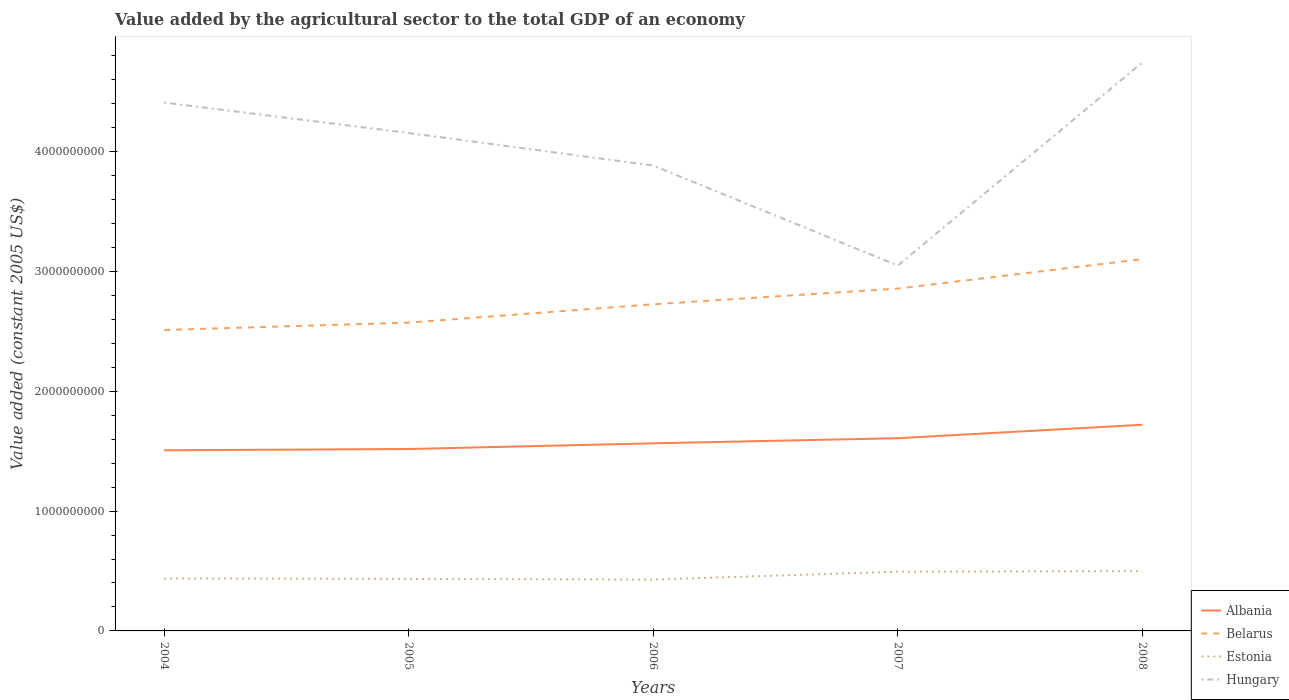How many different coloured lines are there?
Ensure brevity in your answer.  4. Across all years, what is the maximum value added by the agricultural sector in Estonia?
Offer a very short reply. 4.28e+08. In which year was the value added by the agricultural sector in Belarus maximum?
Keep it short and to the point. 2004. What is the total value added by the agricultural sector in Hungary in the graph?
Your answer should be very brief. 2.72e+08. What is the difference between the highest and the second highest value added by the agricultural sector in Estonia?
Ensure brevity in your answer.  7.04e+07. Is the value added by the agricultural sector in Estonia strictly greater than the value added by the agricultural sector in Albania over the years?
Keep it short and to the point. Yes. How many years are there in the graph?
Provide a succinct answer. 5. Does the graph contain grids?
Give a very brief answer. No. Where does the legend appear in the graph?
Provide a succinct answer. Bottom right. How many legend labels are there?
Provide a short and direct response. 4. How are the legend labels stacked?
Offer a terse response. Vertical. What is the title of the graph?
Give a very brief answer. Value added by the agricultural sector to the total GDP of an economy. Does "Sierra Leone" appear as one of the legend labels in the graph?
Offer a terse response. No. What is the label or title of the Y-axis?
Provide a short and direct response. Value added (constant 2005 US$). What is the Value added (constant 2005 US$) of Albania in 2004?
Provide a short and direct response. 1.51e+09. What is the Value added (constant 2005 US$) of Belarus in 2004?
Ensure brevity in your answer.  2.51e+09. What is the Value added (constant 2005 US$) in Estonia in 2004?
Give a very brief answer. 4.38e+08. What is the Value added (constant 2005 US$) of Hungary in 2004?
Ensure brevity in your answer.  4.41e+09. What is the Value added (constant 2005 US$) in Albania in 2005?
Offer a very short reply. 1.52e+09. What is the Value added (constant 2005 US$) of Belarus in 2005?
Offer a very short reply. 2.57e+09. What is the Value added (constant 2005 US$) of Estonia in 2005?
Keep it short and to the point. 4.34e+08. What is the Value added (constant 2005 US$) in Hungary in 2005?
Provide a short and direct response. 4.16e+09. What is the Value added (constant 2005 US$) of Albania in 2006?
Make the answer very short. 1.57e+09. What is the Value added (constant 2005 US$) in Belarus in 2006?
Ensure brevity in your answer.  2.73e+09. What is the Value added (constant 2005 US$) in Estonia in 2006?
Your response must be concise. 4.28e+08. What is the Value added (constant 2005 US$) of Hungary in 2006?
Give a very brief answer. 3.88e+09. What is the Value added (constant 2005 US$) in Albania in 2007?
Give a very brief answer. 1.61e+09. What is the Value added (constant 2005 US$) in Belarus in 2007?
Your response must be concise. 2.86e+09. What is the Value added (constant 2005 US$) in Estonia in 2007?
Your answer should be compact. 4.94e+08. What is the Value added (constant 2005 US$) in Hungary in 2007?
Provide a succinct answer. 3.05e+09. What is the Value added (constant 2005 US$) in Albania in 2008?
Provide a succinct answer. 1.72e+09. What is the Value added (constant 2005 US$) in Belarus in 2008?
Ensure brevity in your answer.  3.10e+09. What is the Value added (constant 2005 US$) in Estonia in 2008?
Your answer should be very brief. 4.99e+08. What is the Value added (constant 2005 US$) of Hungary in 2008?
Your answer should be very brief. 4.75e+09. Across all years, what is the maximum Value added (constant 2005 US$) of Albania?
Your response must be concise. 1.72e+09. Across all years, what is the maximum Value added (constant 2005 US$) in Belarus?
Your response must be concise. 3.10e+09. Across all years, what is the maximum Value added (constant 2005 US$) of Estonia?
Your answer should be very brief. 4.99e+08. Across all years, what is the maximum Value added (constant 2005 US$) in Hungary?
Keep it short and to the point. 4.75e+09. Across all years, what is the minimum Value added (constant 2005 US$) of Albania?
Your answer should be compact. 1.51e+09. Across all years, what is the minimum Value added (constant 2005 US$) in Belarus?
Give a very brief answer. 2.51e+09. Across all years, what is the minimum Value added (constant 2005 US$) of Estonia?
Provide a succinct answer. 4.28e+08. Across all years, what is the minimum Value added (constant 2005 US$) of Hungary?
Your answer should be very brief. 3.05e+09. What is the total Value added (constant 2005 US$) of Albania in the graph?
Your response must be concise. 7.92e+09. What is the total Value added (constant 2005 US$) of Belarus in the graph?
Your answer should be very brief. 1.38e+1. What is the total Value added (constant 2005 US$) in Estonia in the graph?
Ensure brevity in your answer.  2.29e+09. What is the total Value added (constant 2005 US$) of Hungary in the graph?
Keep it short and to the point. 2.02e+1. What is the difference between the Value added (constant 2005 US$) in Albania in 2004 and that in 2005?
Your answer should be very brief. -1.05e+07. What is the difference between the Value added (constant 2005 US$) of Belarus in 2004 and that in 2005?
Your answer should be compact. -6.17e+07. What is the difference between the Value added (constant 2005 US$) of Estonia in 2004 and that in 2005?
Your answer should be compact. 3.88e+06. What is the difference between the Value added (constant 2005 US$) of Hungary in 2004 and that in 2005?
Give a very brief answer. 2.54e+08. What is the difference between the Value added (constant 2005 US$) of Albania in 2004 and that in 2006?
Keep it short and to the point. -5.79e+07. What is the difference between the Value added (constant 2005 US$) of Belarus in 2004 and that in 2006?
Keep it short and to the point. -2.15e+08. What is the difference between the Value added (constant 2005 US$) in Estonia in 2004 and that in 2006?
Your answer should be compact. 9.87e+06. What is the difference between the Value added (constant 2005 US$) in Hungary in 2004 and that in 2006?
Provide a succinct answer. 5.26e+08. What is the difference between the Value added (constant 2005 US$) of Albania in 2004 and that in 2007?
Your response must be concise. -1.01e+08. What is the difference between the Value added (constant 2005 US$) in Belarus in 2004 and that in 2007?
Offer a terse response. -3.46e+08. What is the difference between the Value added (constant 2005 US$) of Estonia in 2004 and that in 2007?
Your answer should be very brief. -5.62e+07. What is the difference between the Value added (constant 2005 US$) of Hungary in 2004 and that in 2007?
Provide a succinct answer. 1.36e+09. What is the difference between the Value added (constant 2005 US$) of Albania in 2004 and that in 2008?
Offer a terse response. -2.13e+08. What is the difference between the Value added (constant 2005 US$) in Belarus in 2004 and that in 2008?
Make the answer very short. -5.92e+08. What is the difference between the Value added (constant 2005 US$) in Estonia in 2004 and that in 2008?
Ensure brevity in your answer.  -6.05e+07. What is the difference between the Value added (constant 2005 US$) of Hungary in 2004 and that in 2008?
Make the answer very short. -3.35e+08. What is the difference between the Value added (constant 2005 US$) in Albania in 2005 and that in 2006?
Ensure brevity in your answer.  -4.75e+07. What is the difference between the Value added (constant 2005 US$) of Belarus in 2005 and that in 2006?
Make the answer very short. -1.53e+08. What is the difference between the Value added (constant 2005 US$) of Estonia in 2005 and that in 2006?
Your answer should be very brief. 5.99e+06. What is the difference between the Value added (constant 2005 US$) in Hungary in 2005 and that in 2006?
Make the answer very short. 2.72e+08. What is the difference between the Value added (constant 2005 US$) of Albania in 2005 and that in 2007?
Your response must be concise. -9.02e+07. What is the difference between the Value added (constant 2005 US$) of Belarus in 2005 and that in 2007?
Give a very brief answer. -2.84e+08. What is the difference between the Value added (constant 2005 US$) in Estonia in 2005 and that in 2007?
Provide a short and direct response. -6.01e+07. What is the difference between the Value added (constant 2005 US$) of Hungary in 2005 and that in 2007?
Your response must be concise. 1.11e+09. What is the difference between the Value added (constant 2005 US$) of Albania in 2005 and that in 2008?
Offer a very short reply. -2.02e+08. What is the difference between the Value added (constant 2005 US$) of Belarus in 2005 and that in 2008?
Your answer should be compact. -5.30e+08. What is the difference between the Value added (constant 2005 US$) of Estonia in 2005 and that in 2008?
Your answer should be compact. -6.44e+07. What is the difference between the Value added (constant 2005 US$) of Hungary in 2005 and that in 2008?
Provide a short and direct response. -5.89e+08. What is the difference between the Value added (constant 2005 US$) in Albania in 2006 and that in 2007?
Offer a very short reply. -4.27e+07. What is the difference between the Value added (constant 2005 US$) in Belarus in 2006 and that in 2007?
Offer a very short reply. -1.31e+08. What is the difference between the Value added (constant 2005 US$) in Estonia in 2006 and that in 2007?
Your response must be concise. -6.61e+07. What is the difference between the Value added (constant 2005 US$) in Hungary in 2006 and that in 2007?
Your answer should be very brief. 8.35e+08. What is the difference between the Value added (constant 2005 US$) in Albania in 2006 and that in 2008?
Your answer should be compact. -1.55e+08. What is the difference between the Value added (constant 2005 US$) in Belarus in 2006 and that in 2008?
Make the answer very short. -3.77e+08. What is the difference between the Value added (constant 2005 US$) in Estonia in 2006 and that in 2008?
Offer a very short reply. -7.04e+07. What is the difference between the Value added (constant 2005 US$) of Hungary in 2006 and that in 2008?
Provide a succinct answer. -8.61e+08. What is the difference between the Value added (constant 2005 US$) of Albania in 2007 and that in 2008?
Make the answer very short. -1.12e+08. What is the difference between the Value added (constant 2005 US$) in Belarus in 2007 and that in 2008?
Your response must be concise. -2.46e+08. What is the difference between the Value added (constant 2005 US$) in Estonia in 2007 and that in 2008?
Ensure brevity in your answer.  -4.29e+06. What is the difference between the Value added (constant 2005 US$) of Hungary in 2007 and that in 2008?
Provide a succinct answer. -1.70e+09. What is the difference between the Value added (constant 2005 US$) in Albania in 2004 and the Value added (constant 2005 US$) in Belarus in 2005?
Provide a short and direct response. -1.07e+09. What is the difference between the Value added (constant 2005 US$) of Albania in 2004 and the Value added (constant 2005 US$) of Estonia in 2005?
Give a very brief answer. 1.07e+09. What is the difference between the Value added (constant 2005 US$) in Albania in 2004 and the Value added (constant 2005 US$) in Hungary in 2005?
Provide a short and direct response. -2.65e+09. What is the difference between the Value added (constant 2005 US$) of Belarus in 2004 and the Value added (constant 2005 US$) of Estonia in 2005?
Provide a short and direct response. 2.08e+09. What is the difference between the Value added (constant 2005 US$) in Belarus in 2004 and the Value added (constant 2005 US$) in Hungary in 2005?
Ensure brevity in your answer.  -1.64e+09. What is the difference between the Value added (constant 2005 US$) of Estonia in 2004 and the Value added (constant 2005 US$) of Hungary in 2005?
Provide a succinct answer. -3.72e+09. What is the difference between the Value added (constant 2005 US$) in Albania in 2004 and the Value added (constant 2005 US$) in Belarus in 2006?
Your response must be concise. -1.22e+09. What is the difference between the Value added (constant 2005 US$) in Albania in 2004 and the Value added (constant 2005 US$) in Estonia in 2006?
Offer a terse response. 1.08e+09. What is the difference between the Value added (constant 2005 US$) of Albania in 2004 and the Value added (constant 2005 US$) of Hungary in 2006?
Offer a very short reply. -2.38e+09. What is the difference between the Value added (constant 2005 US$) in Belarus in 2004 and the Value added (constant 2005 US$) in Estonia in 2006?
Your answer should be very brief. 2.08e+09. What is the difference between the Value added (constant 2005 US$) in Belarus in 2004 and the Value added (constant 2005 US$) in Hungary in 2006?
Your answer should be very brief. -1.37e+09. What is the difference between the Value added (constant 2005 US$) in Estonia in 2004 and the Value added (constant 2005 US$) in Hungary in 2006?
Your answer should be very brief. -3.45e+09. What is the difference between the Value added (constant 2005 US$) of Albania in 2004 and the Value added (constant 2005 US$) of Belarus in 2007?
Make the answer very short. -1.35e+09. What is the difference between the Value added (constant 2005 US$) in Albania in 2004 and the Value added (constant 2005 US$) in Estonia in 2007?
Keep it short and to the point. 1.01e+09. What is the difference between the Value added (constant 2005 US$) in Albania in 2004 and the Value added (constant 2005 US$) in Hungary in 2007?
Give a very brief answer. -1.54e+09. What is the difference between the Value added (constant 2005 US$) in Belarus in 2004 and the Value added (constant 2005 US$) in Estonia in 2007?
Your response must be concise. 2.02e+09. What is the difference between the Value added (constant 2005 US$) of Belarus in 2004 and the Value added (constant 2005 US$) of Hungary in 2007?
Keep it short and to the point. -5.38e+08. What is the difference between the Value added (constant 2005 US$) of Estonia in 2004 and the Value added (constant 2005 US$) of Hungary in 2007?
Provide a succinct answer. -2.61e+09. What is the difference between the Value added (constant 2005 US$) in Albania in 2004 and the Value added (constant 2005 US$) in Belarus in 2008?
Offer a terse response. -1.60e+09. What is the difference between the Value added (constant 2005 US$) in Albania in 2004 and the Value added (constant 2005 US$) in Estonia in 2008?
Your answer should be very brief. 1.01e+09. What is the difference between the Value added (constant 2005 US$) in Albania in 2004 and the Value added (constant 2005 US$) in Hungary in 2008?
Your response must be concise. -3.24e+09. What is the difference between the Value added (constant 2005 US$) of Belarus in 2004 and the Value added (constant 2005 US$) of Estonia in 2008?
Make the answer very short. 2.01e+09. What is the difference between the Value added (constant 2005 US$) of Belarus in 2004 and the Value added (constant 2005 US$) of Hungary in 2008?
Offer a terse response. -2.23e+09. What is the difference between the Value added (constant 2005 US$) in Estonia in 2004 and the Value added (constant 2005 US$) in Hungary in 2008?
Your answer should be very brief. -4.31e+09. What is the difference between the Value added (constant 2005 US$) of Albania in 2005 and the Value added (constant 2005 US$) of Belarus in 2006?
Provide a succinct answer. -1.21e+09. What is the difference between the Value added (constant 2005 US$) in Albania in 2005 and the Value added (constant 2005 US$) in Estonia in 2006?
Offer a terse response. 1.09e+09. What is the difference between the Value added (constant 2005 US$) in Albania in 2005 and the Value added (constant 2005 US$) in Hungary in 2006?
Provide a short and direct response. -2.37e+09. What is the difference between the Value added (constant 2005 US$) of Belarus in 2005 and the Value added (constant 2005 US$) of Estonia in 2006?
Ensure brevity in your answer.  2.15e+09. What is the difference between the Value added (constant 2005 US$) in Belarus in 2005 and the Value added (constant 2005 US$) in Hungary in 2006?
Keep it short and to the point. -1.31e+09. What is the difference between the Value added (constant 2005 US$) of Estonia in 2005 and the Value added (constant 2005 US$) of Hungary in 2006?
Provide a succinct answer. -3.45e+09. What is the difference between the Value added (constant 2005 US$) of Albania in 2005 and the Value added (constant 2005 US$) of Belarus in 2007?
Give a very brief answer. -1.34e+09. What is the difference between the Value added (constant 2005 US$) of Albania in 2005 and the Value added (constant 2005 US$) of Estonia in 2007?
Offer a terse response. 1.02e+09. What is the difference between the Value added (constant 2005 US$) in Albania in 2005 and the Value added (constant 2005 US$) in Hungary in 2007?
Keep it short and to the point. -1.53e+09. What is the difference between the Value added (constant 2005 US$) of Belarus in 2005 and the Value added (constant 2005 US$) of Estonia in 2007?
Ensure brevity in your answer.  2.08e+09. What is the difference between the Value added (constant 2005 US$) in Belarus in 2005 and the Value added (constant 2005 US$) in Hungary in 2007?
Give a very brief answer. -4.76e+08. What is the difference between the Value added (constant 2005 US$) in Estonia in 2005 and the Value added (constant 2005 US$) in Hungary in 2007?
Keep it short and to the point. -2.62e+09. What is the difference between the Value added (constant 2005 US$) in Albania in 2005 and the Value added (constant 2005 US$) in Belarus in 2008?
Your answer should be very brief. -1.58e+09. What is the difference between the Value added (constant 2005 US$) of Albania in 2005 and the Value added (constant 2005 US$) of Estonia in 2008?
Your response must be concise. 1.02e+09. What is the difference between the Value added (constant 2005 US$) in Albania in 2005 and the Value added (constant 2005 US$) in Hungary in 2008?
Your answer should be very brief. -3.23e+09. What is the difference between the Value added (constant 2005 US$) of Belarus in 2005 and the Value added (constant 2005 US$) of Estonia in 2008?
Provide a short and direct response. 2.07e+09. What is the difference between the Value added (constant 2005 US$) of Belarus in 2005 and the Value added (constant 2005 US$) of Hungary in 2008?
Provide a short and direct response. -2.17e+09. What is the difference between the Value added (constant 2005 US$) of Estonia in 2005 and the Value added (constant 2005 US$) of Hungary in 2008?
Your answer should be compact. -4.31e+09. What is the difference between the Value added (constant 2005 US$) in Albania in 2006 and the Value added (constant 2005 US$) in Belarus in 2007?
Provide a succinct answer. -1.29e+09. What is the difference between the Value added (constant 2005 US$) in Albania in 2006 and the Value added (constant 2005 US$) in Estonia in 2007?
Give a very brief answer. 1.07e+09. What is the difference between the Value added (constant 2005 US$) in Albania in 2006 and the Value added (constant 2005 US$) in Hungary in 2007?
Give a very brief answer. -1.48e+09. What is the difference between the Value added (constant 2005 US$) of Belarus in 2006 and the Value added (constant 2005 US$) of Estonia in 2007?
Ensure brevity in your answer.  2.23e+09. What is the difference between the Value added (constant 2005 US$) of Belarus in 2006 and the Value added (constant 2005 US$) of Hungary in 2007?
Give a very brief answer. -3.23e+08. What is the difference between the Value added (constant 2005 US$) in Estonia in 2006 and the Value added (constant 2005 US$) in Hungary in 2007?
Offer a very short reply. -2.62e+09. What is the difference between the Value added (constant 2005 US$) of Albania in 2006 and the Value added (constant 2005 US$) of Belarus in 2008?
Make the answer very short. -1.54e+09. What is the difference between the Value added (constant 2005 US$) of Albania in 2006 and the Value added (constant 2005 US$) of Estonia in 2008?
Your answer should be very brief. 1.07e+09. What is the difference between the Value added (constant 2005 US$) of Albania in 2006 and the Value added (constant 2005 US$) of Hungary in 2008?
Your answer should be very brief. -3.18e+09. What is the difference between the Value added (constant 2005 US$) of Belarus in 2006 and the Value added (constant 2005 US$) of Estonia in 2008?
Your response must be concise. 2.23e+09. What is the difference between the Value added (constant 2005 US$) of Belarus in 2006 and the Value added (constant 2005 US$) of Hungary in 2008?
Offer a very short reply. -2.02e+09. What is the difference between the Value added (constant 2005 US$) of Estonia in 2006 and the Value added (constant 2005 US$) of Hungary in 2008?
Your answer should be compact. -4.32e+09. What is the difference between the Value added (constant 2005 US$) in Albania in 2007 and the Value added (constant 2005 US$) in Belarus in 2008?
Provide a succinct answer. -1.49e+09. What is the difference between the Value added (constant 2005 US$) in Albania in 2007 and the Value added (constant 2005 US$) in Estonia in 2008?
Provide a succinct answer. 1.11e+09. What is the difference between the Value added (constant 2005 US$) in Albania in 2007 and the Value added (constant 2005 US$) in Hungary in 2008?
Give a very brief answer. -3.14e+09. What is the difference between the Value added (constant 2005 US$) of Belarus in 2007 and the Value added (constant 2005 US$) of Estonia in 2008?
Offer a terse response. 2.36e+09. What is the difference between the Value added (constant 2005 US$) of Belarus in 2007 and the Value added (constant 2005 US$) of Hungary in 2008?
Provide a short and direct response. -1.89e+09. What is the difference between the Value added (constant 2005 US$) of Estonia in 2007 and the Value added (constant 2005 US$) of Hungary in 2008?
Provide a succinct answer. -4.25e+09. What is the average Value added (constant 2005 US$) of Albania per year?
Keep it short and to the point. 1.58e+09. What is the average Value added (constant 2005 US$) of Belarus per year?
Provide a succinct answer. 2.75e+09. What is the average Value added (constant 2005 US$) of Estonia per year?
Your answer should be compact. 4.59e+08. What is the average Value added (constant 2005 US$) in Hungary per year?
Provide a succinct answer. 4.05e+09. In the year 2004, what is the difference between the Value added (constant 2005 US$) in Albania and Value added (constant 2005 US$) in Belarus?
Keep it short and to the point. -1.00e+09. In the year 2004, what is the difference between the Value added (constant 2005 US$) in Albania and Value added (constant 2005 US$) in Estonia?
Keep it short and to the point. 1.07e+09. In the year 2004, what is the difference between the Value added (constant 2005 US$) of Albania and Value added (constant 2005 US$) of Hungary?
Keep it short and to the point. -2.90e+09. In the year 2004, what is the difference between the Value added (constant 2005 US$) in Belarus and Value added (constant 2005 US$) in Estonia?
Make the answer very short. 2.07e+09. In the year 2004, what is the difference between the Value added (constant 2005 US$) of Belarus and Value added (constant 2005 US$) of Hungary?
Your answer should be compact. -1.90e+09. In the year 2004, what is the difference between the Value added (constant 2005 US$) in Estonia and Value added (constant 2005 US$) in Hungary?
Keep it short and to the point. -3.97e+09. In the year 2005, what is the difference between the Value added (constant 2005 US$) of Albania and Value added (constant 2005 US$) of Belarus?
Ensure brevity in your answer.  -1.06e+09. In the year 2005, what is the difference between the Value added (constant 2005 US$) of Albania and Value added (constant 2005 US$) of Estonia?
Keep it short and to the point. 1.08e+09. In the year 2005, what is the difference between the Value added (constant 2005 US$) in Albania and Value added (constant 2005 US$) in Hungary?
Your response must be concise. -2.64e+09. In the year 2005, what is the difference between the Value added (constant 2005 US$) in Belarus and Value added (constant 2005 US$) in Estonia?
Make the answer very short. 2.14e+09. In the year 2005, what is the difference between the Value added (constant 2005 US$) in Belarus and Value added (constant 2005 US$) in Hungary?
Give a very brief answer. -1.58e+09. In the year 2005, what is the difference between the Value added (constant 2005 US$) in Estonia and Value added (constant 2005 US$) in Hungary?
Your answer should be compact. -3.72e+09. In the year 2006, what is the difference between the Value added (constant 2005 US$) in Albania and Value added (constant 2005 US$) in Belarus?
Provide a short and direct response. -1.16e+09. In the year 2006, what is the difference between the Value added (constant 2005 US$) of Albania and Value added (constant 2005 US$) of Estonia?
Offer a terse response. 1.14e+09. In the year 2006, what is the difference between the Value added (constant 2005 US$) of Albania and Value added (constant 2005 US$) of Hungary?
Make the answer very short. -2.32e+09. In the year 2006, what is the difference between the Value added (constant 2005 US$) in Belarus and Value added (constant 2005 US$) in Estonia?
Provide a succinct answer. 2.30e+09. In the year 2006, what is the difference between the Value added (constant 2005 US$) in Belarus and Value added (constant 2005 US$) in Hungary?
Ensure brevity in your answer.  -1.16e+09. In the year 2006, what is the difference between the Value added (constant 2005 US$) in Estonia and Value added (constant 2005 US$) in Hungary?
Provide a succinct answer. -3.46e+09. In the year 2007, what is the difference between the Value added (constant 2005 US$) of Albania and Value added (constant 2005 US$) of Belarus?
Make the answer very short. -1.25e+09. In the year 2007, what is the difference between the Value added (constant 2005 US$) in Albania and Value added (constant 2005 US$) in Estonia?
Offer a terse response. 1.11e+09. In the year 2007, what is the difference between the Value added (constant 2005 US$) of Albania and Value added (constant 2005 US$) of Hungary?
Offer a very short reply. -1.44e+09. In the year 2007, what is the difference between the Value added (constant 2005 US$) in Belarus and Value added (constant 2005 US$) in Estonia?
Your answer should be compact. 2.36e+09. In the year 2007, what is the difference between the Value added (constant 2005 US$) of Belarus and Value added (constant 2005 US$) of Hungary?
Keep it short and to the point. -1.92e+08. In the year 2007, what is the difference between the Value added (constant 2005 US$) of Estonia and Value added (constant 2005 US$) of Hungary?
Your answer should be very brief. -2.56e+09. In the year 2008, what is the difference between the Value added (constant 2005 US$) in Albania and Value added (constant 2005 US$) in Belarus?
Provide a short and direct response. -1.38e+09. In the year 2008, what is the difference between the Value added (constant 2005 US$) in Albania and Value added (constant 2005 US$) in Estonia?
Provide a short and direct response. 1.22e+09. In the year 2008, what is the difference between the Value added (constant 2005 US$) in Albania and Value added (constant 2005 US$) in Hungary?
Ensure brevity in your answer.  -3.02e+09. In the year 2008, what is the difference between the Value added (constant 2005 US$) of Belarus and Value added (constant 2005 US$) of Estonia?
Provide a succinct answer. 2.60e+09. In the year 2008, what is the difference between the Value added (constant 2005 US$) in Belarus and Value added (constant 2005 US$) in Hungary?
Offer a very short reply. -1.64e+09. In the year 2008, what is the difference between the Value added (constant 2005 US$) in Estonia and Value added (constant 2005 US$) in Hungary?
Your response must be concise. -4.25e+09. What is the ratio of the Value added (constant 2005 US$) in Albania in 2004 to that in 2005?
Keep it short and to the point. 0.99. What is the ratio of the Value added (constant 2005 US$) in Belarus in 2004 to that in 2005?
Keep it short and to the point. 0.98. What is the ratio of the Value added (constant 2005 US$) in Estonia in 2004 to that in 2005?
Ensure brevity in your answer.  1.01. What is the ratio of the Value added (constant 2005 US$) in Hungary in 2004 to that in 2005?
Keep it short and to the point. 1.06. What is the ratio of the Value added (constant 2005 US$) of Albania in 2004 to that in 2006?
Give a very brief answer. 0.96. What is the ratio of the Value added (constant 2005 US$) in Belarus in 2004 to that in 2006?
Your answer should be compact. 0.92. What is the ratio of the Value added (constant 2005 US$) of Estonia in 2004 to that in 2006?
Offer a very short reply. 1.02. What is the ratio of the Value added (constant 2005 US$) of Hungary in 2004 to that in 2006?
Provide a succinct answer. 1.14. What is the ratio of the Value added (constant 2005 US$) in Albania in 2004 to that in 2007?
Make the answer very short. 0.94. What is the ratio of the Value added (constant 2005 US$) in Belarus in 2004 to that in 2007?
Your answer should be very brief. 0.88. What is the ratio of the Value added (constant 2005 US$) of Estonia in 2004 to that in 2007?
Keep it short and to the point. 0.89. What is the ratio of the Value added (constant 2005 US$) in Hungary in 2004 to that in 2007?
Offer a very short reply. 1.45. What is the ratio of the Value added (constant 2005 US$) of Albania in 2004 to that in 2008?
Provide a short and direct response. 0.88. What is the ratio of the Value added (constant 2005 US$) of Belarus in 2004 to that in 2008?
Your answer should be very brief. 0.81. What is the ratio of the Value added (constant 2005 US$) of Estonia in 2004 to that in 2008?
Give a very brief answer. 0.88. What is the ratio of the Value added (constant 2005 US$) of Hungary in 2004 to that in 2008?
Your answer should be compact. 0.93. What is the ratio of the Value added (constant 2005 US$) of Albania in 2005 to that in 2006?
Your response must be concise. 0.97. What is the ratio of the Value added (constant 2005 US$) of Belarus in 2005 to that in 2006?
Keep it short and to the point. 0.94. What is the ratio of the Value added (constant 2005 US$) in Estonia in 2005 to that in 2006?
Provide a succinct answer. 1.01. What is the ratio of the Value added (constant 2005 US$) of Hungary in 2005 to that in 2006?
Your response must be concise. 1.07. What is the ratio of the Value added (constant 2005 US$) in Albania in 2005 to that in 2007?
Provide a short and direct response. 0.94. What is the ratio of the Value added (constant 2005 US$) of Belarus in 2005 to that in 2007?
Your response must be concise. 0.9. What is the ratio of the Value added (constant 2005 US$) in Estonia in 2005 to that in 2007?
Your response must be concise. 0.88. What is the ratio of the Value added (constant 2005 US$) of Hungary in 2005 to that in 2007?
Your answer should be compact. 1.36. What is the ratio of the Value added (constant 2005 US$) in Albania in 2005 to that in 2008?
Give a very brief answer. 0.88. What is the ratio of the Value added (constant 2005 US$) in Belarus in 2005 to that in 2008?
Your answer should be compact. 0.83. What is the ratio of the Value added (constant 2005 US$) in Estonia in 2005 to that in 2008?
Offer a very short reply. 0.87. What is the ratio of the Value added (constant 2005 US$) in Hungary in 2005 to that in 2008?
Give a very brief answer. 0.88. What is the ratio of the Value added (constant 2005 US$) of Albania in 2006 to that in 2007?
Make the answer very short. 0.97. What is the ratio of the Value added (constant 2005 US$) of Belarus in 2006 to that in 2007?
Keep it short and to the point. 0.95. What is the ratio of the Value added (constant 2005 US$) of Estonia in 2006 to that in 2007?
Your answer should be very brief. 0.87. What is the ratio of the Value added (constant 2005 US$) in Hungary in 2006 to that in 2007?
Your answer should be compact. 1.27. What is the ratio of the Value added (constant 2005 US$) in Albania in 2006 to that in 2008?
Your answer should be very brief. 0.91. What is the ratio of the Value added (constant 2005 US$) of Belarus in 2006 to that in 2008?
Your answer should be very brief. 0.88. What is the ratio of the Value added (constant 2005 US$) of Estonia in 2006 to that in 2008?
Provide a short and direct response. 0.86. What is the ratio of the Value added (constant 2005 US$) in Hungary in 2006 to that in 2008?
Provide a short and direct response. 0.82. What is the ratio of the Value added (constant 2005 US$) in Albania in 2007 to that in 2008?
Offer a terse response. 0.93. What is the ratio of the Value added (constant 2005 US$) in Belarus in 2007 to that in 2008?
Provide a succinct answer. 0.92. What is the ratio of the Value added (constant 2005 US$) of Estonia in 2007 to that in 2008?
Provide a short and direct response. 0.99. What is the ratio of the Value added (constant 2005 US$) in Hungary in 2007 to that in 2008?
Provide a short and direct response. 0.64. What is the difference between the highest and the second highest Value added (constant 2005 US$) in Albania?
Your response must be concise. 1.12e+08. What is the difference between the highest and the second highest Value added (constant 2005 US$) in Belarus?
Your answer should be compact. 2.46e+08. What is the difference between the highest and the second highest Value added (constant 2005 US$) in Estonia?
Offer a terse response. 4.29e+06. What is the difference between the highest and the second highest Value added (constant 2005 US$) in Hungary?
Make the answer very short. 3.35e+08. What is the difference between the highest and the lowest Value added (constant 2005 US$) in Albania?
Keep it short and to the point. 2.13e+08. What is the difference between the highest and the lowest Value added (constant 2005 US$) of Belarus?
Your answer should be compact. 5.92e+08. What is the difference between the highest and the lowest Value added (constant 2005 US$) of Estonia?
Ensure brevity in your answer.  7.04e+07. What is the difference between the highest and the lowest Value added (constant 2005 US$) in Hungary?
Give a very brief answer. 1.70e+09. 